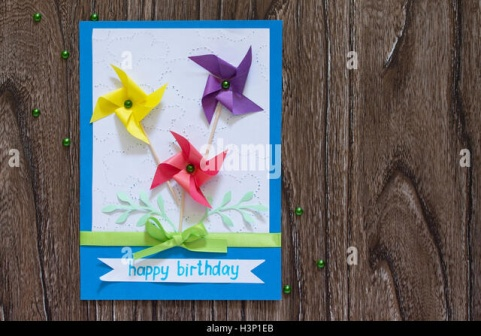Compose a poetic description of the card scene. In the gentle embrace of a wooden realm, a card awaits, bordered in azure calm. Whispers of green foliage dance across its face, cradling pinwheels spun from the joy of springtime days. In hues of sunburst yellow, amethyst dreams, and ruby laughter, they whirl on stems of emerald grace. A ribbon, as green as new leaves kissed by dawn, binds the wishes of a 'happy birthday' written in the language of warmth and cheer. Around them, tiny pearls of forest green lie in playful disarray, like sparkles from a fairy's flight. The scene breathes life, celebration, and the simple bliss of a handmade token of affection. 